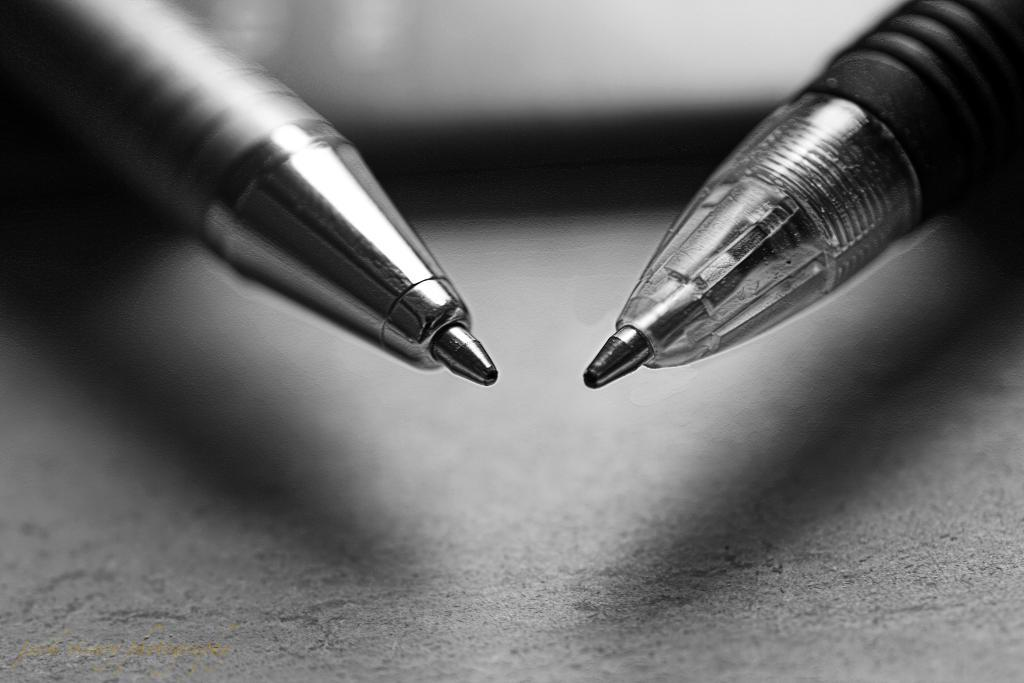What stationery items can be seen in the image? There are pens in the image. Can you describe the pens in more detail? Unfortunately, the image does not provide enough detail to describe the pens further. What type of road can be seen in the image? There is no road present in the image; it only features pens. Where might these pens be stored in the image? The image does not show a shelf or any other storage area for the pens. 